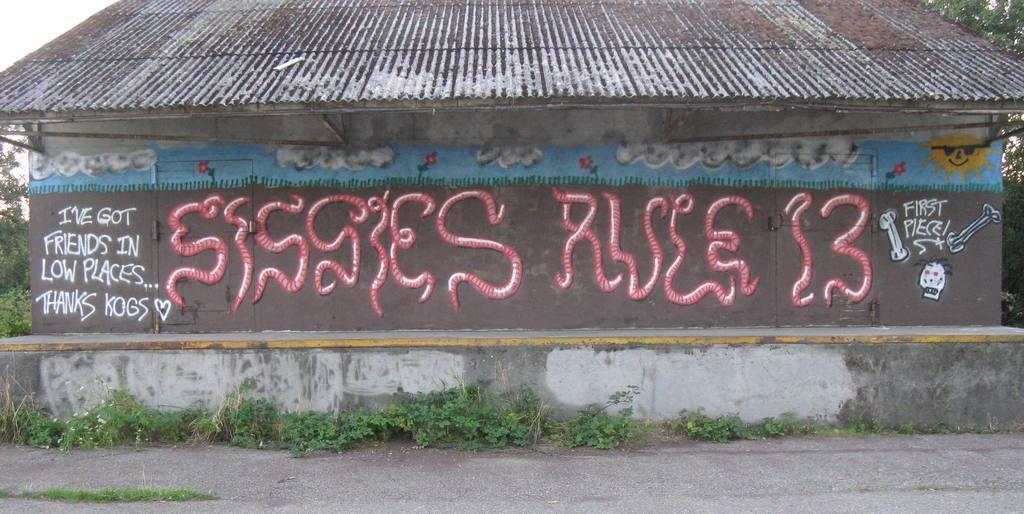Could you give a brief overview of what you see in this image? In the center of the image there is a house and there is some painting on the walls of the house. At the bottom of the image there is road. There are plants. 